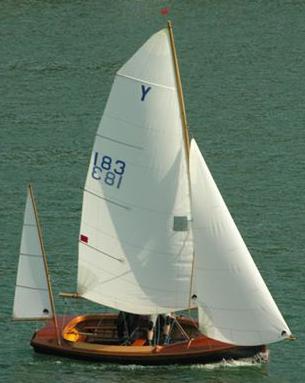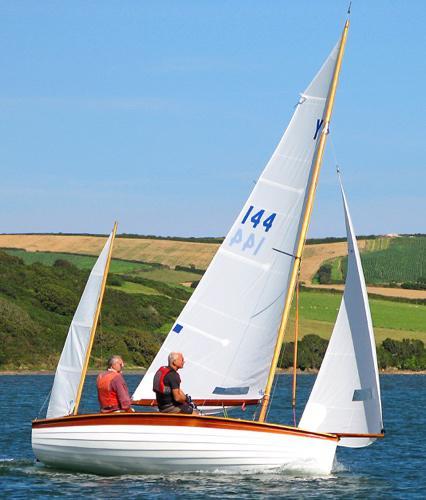The first image is the image on the left, the second image is the image on the right. Given the left and right images, does the statement "There are at least five boats visible." hold true? Answer yes or no. No. The first image is the image on the left, the second image is the image on the right. Examine the images to the left and right. Is the description "in at least one image there is a single boat with 3 raised sails" accurate? Answer yes or no. Yes. 